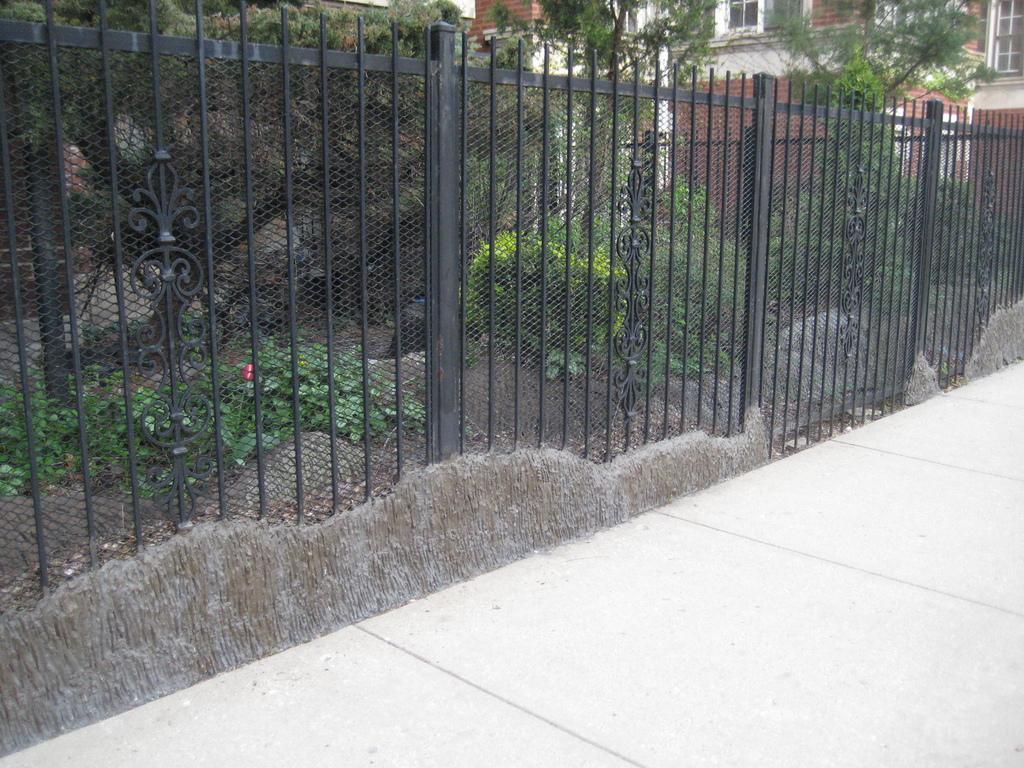How would you summarize this image in a sentence or two? In the middle of the image there is a fencing. Behind the fencing there are some plants and trees. Behind the trees there is a building. 